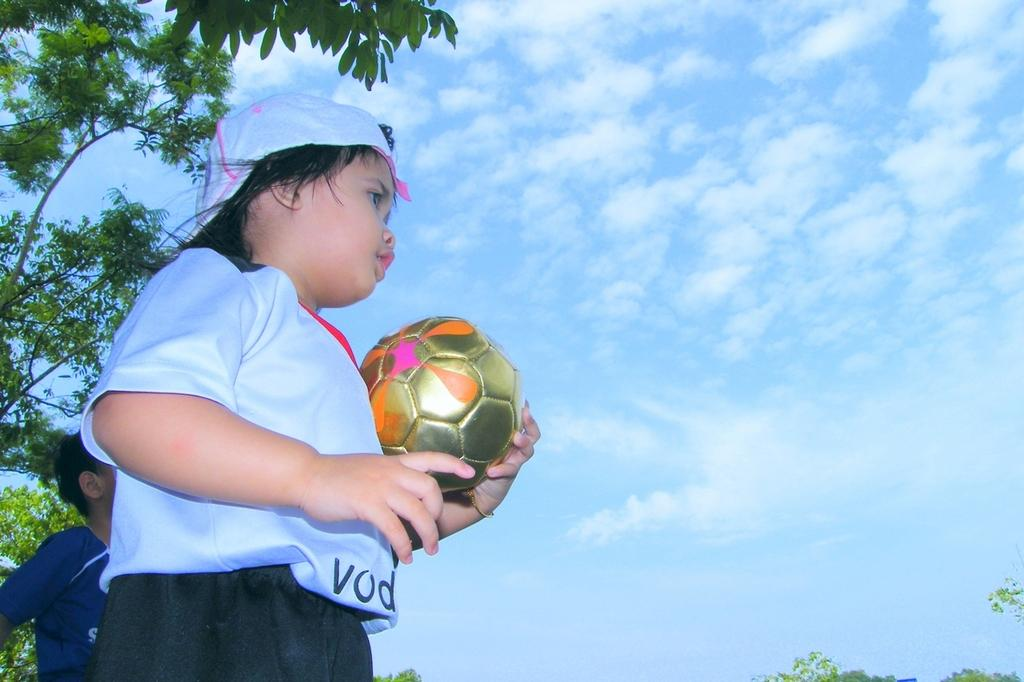What is the child in the image doing? The child is standing in the image and holding a ball in his hands. Can you describe the person in the background? There is a person standing in the background, but no specific details about them are provided. What can be seen in the image besides the child and the person in the background? There is a tree in the image, and the sky is cloudy. What is the reaction of the child to the sudden increase in profit in the image? There is no mention of profit or any financial context in the image, so it is not possible to determine the child's reaction to it. 